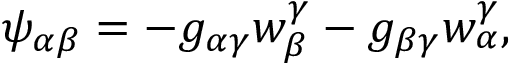Convert formula to latex. <formula><loc_0><loc_0><loc_500><loc_500>\psi _ { \alpha \beta } = - g _ { \alpha \gamma } w _ { \beta } ^ { \gamma } - g _ { \beta \gamma } w _ { \alpha } ^ { \gamma } ,</formula> 